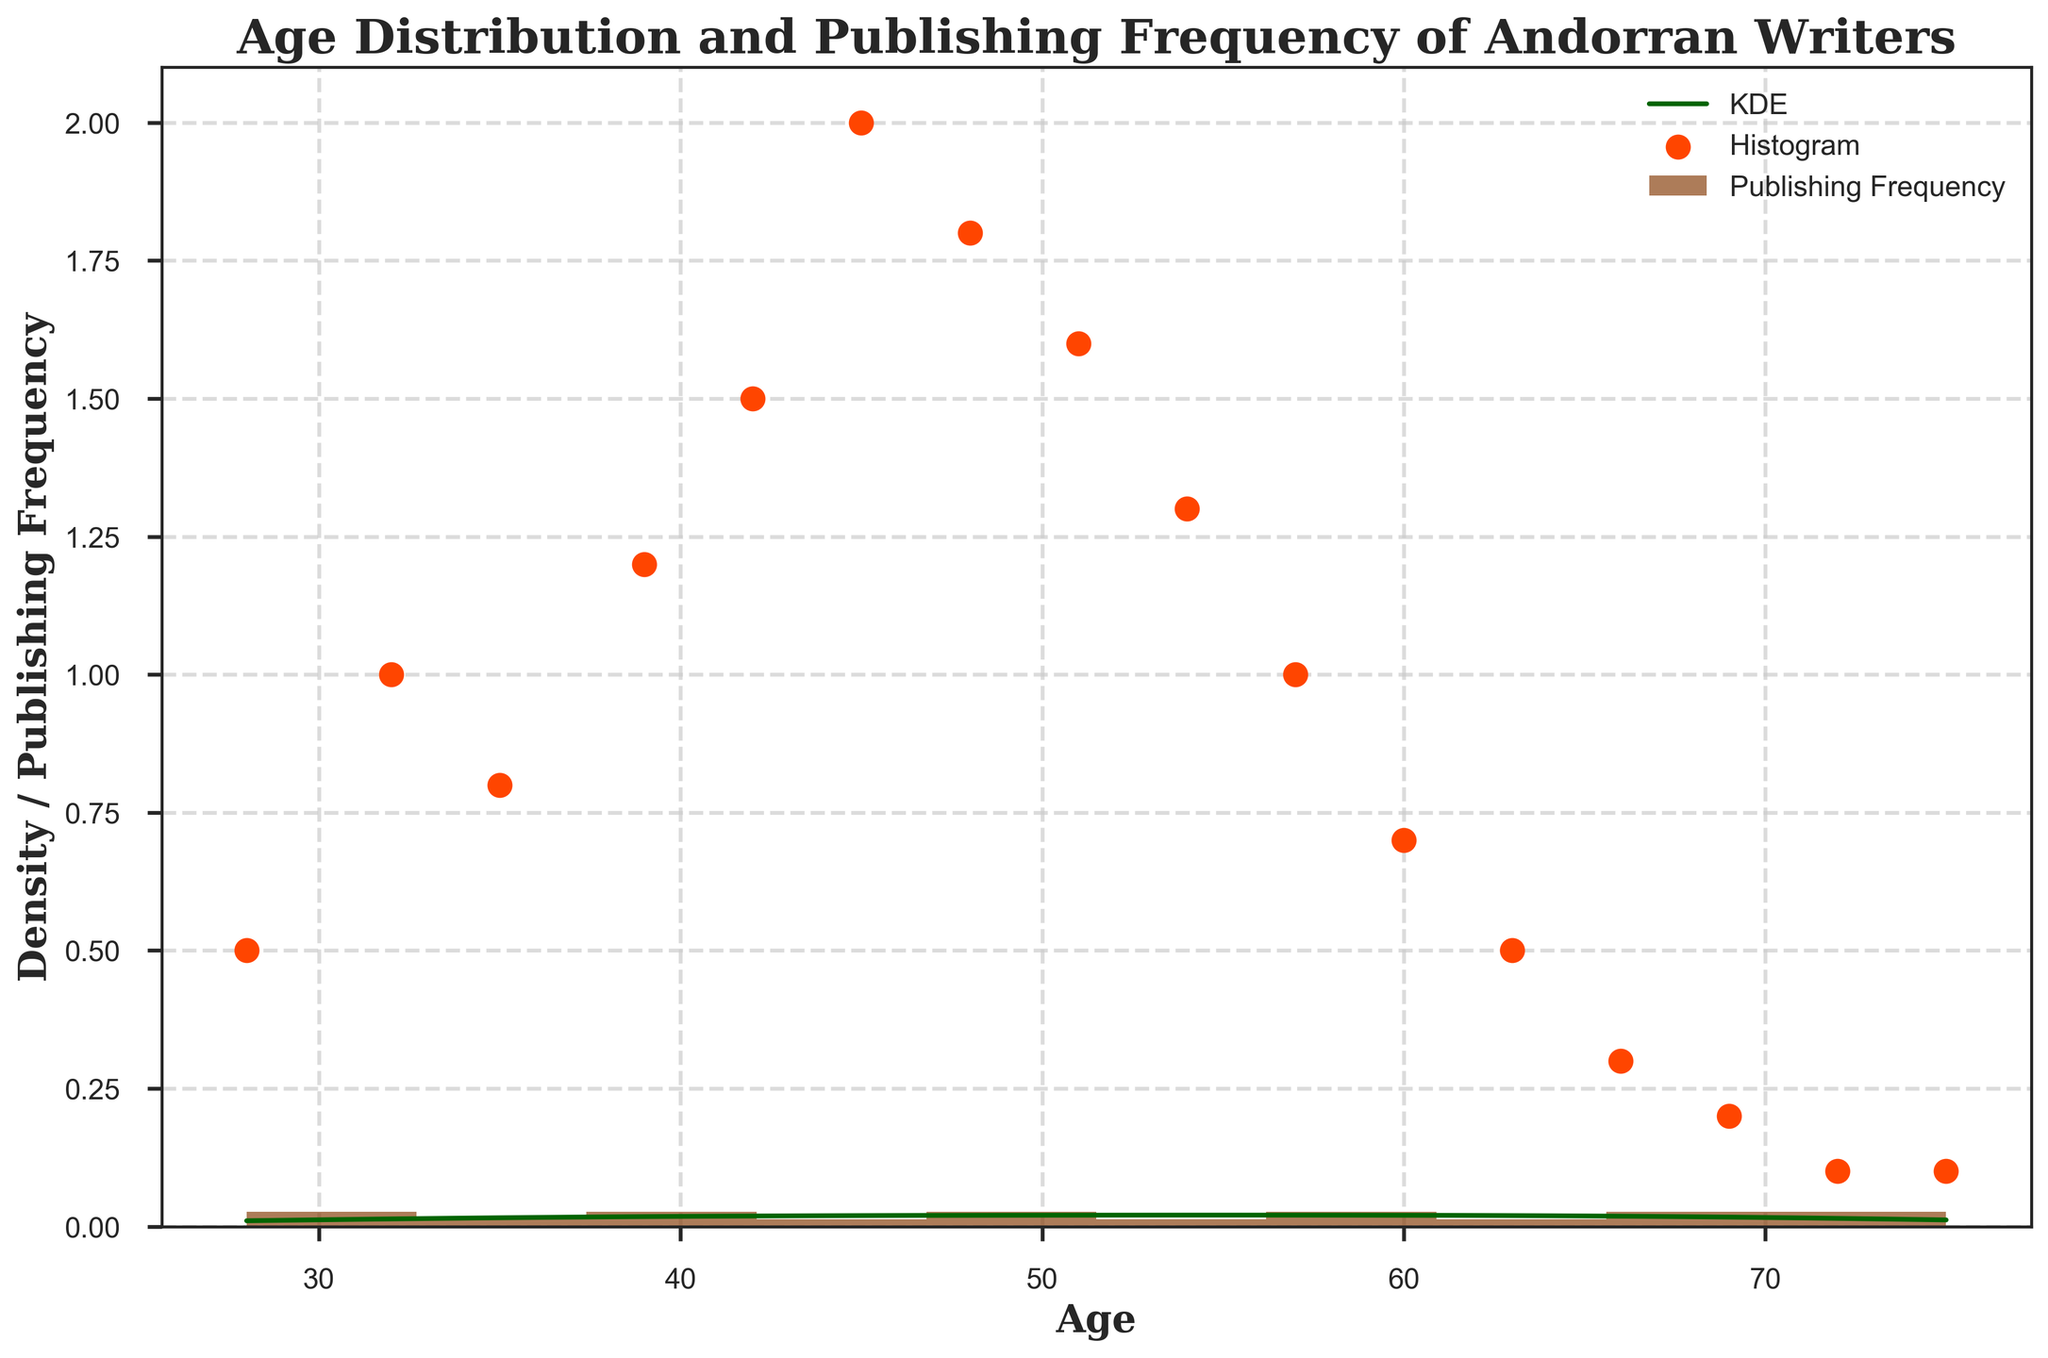What's the title of the figure? The title of the figure is usually located at the top and summarizes the content of the plot. In this case, the title reads "Age Distribution and Publishing Frequency of Andorran Writers".
Answer: Age Distribution and Publishing Frequency of Andorran Writers How is publishing frequency represented in the figure? The publishing frequency is shown using orange scatter points positioned along the age values.
Answer: Orange scatter points Which age group has the highest density according to the KDE curve? By observing the KDE curve (in dark green), the peak of the density occurs around the ages of 45-48. This indicates the highest density of writers around this age group.
Answer: 45-48 How many bins are used in the histogram? The number of bins in the histogram can be counted directly. There are 10 bins present, as specified in the code.
Answer: 10 What is the color of the histogram bars? The bars of the histogram are colored in a shade of brown (#8B4513).
Answer: Brown Compare the publishing frequencies of writers aged 28 and 45. Which age has a higher publishing frequency? By observing the scatter points, we can see that a 45-year-old has a publishing frequency of 2, whereas a 28-year-old has a publishing frequency of 0.5. Thus, the 45-year-old has a higher publishing frequency.
Answer: 45 Which age group of Andorran writers has the lowest publishing frequency, and what is this frequency? The lowest publishing frequency, visible in the scatter points, is for writers aged 72, 75, 69, and 66. They all have frequencies below 0.2, with 72 and 75 having the lowest frequency of 0.1.
Answer: 72 and 75; 0.1 Where are the axes labels situated and what do they represent? The axis labels are located along the x-axis and y-axis. The x-axis label is "Age", and the y-axis label is "Density / Publishing Frequency", indicating what each axis represents.
Answer: "Age" (x-axis) and "Density / Publishing Frequency" (y-axis) How does the publishing frequency change with age according to the scatter plot? The scatter plot suggests that the publishing frequency generally increases from ages 28 to 45 and then decreases progressively as age increases.
Answer: Increases till 45, then decreases 